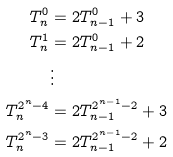Convert formula to latex. <formula><loc_0><loc_0><loc_500><loc_500>T ^ { 0 } _ { n } & = 2 T ^ { 0 } _ { n - 1 } + 3 \\ T ^ { 1 } _ { n } & = 2 T ^ { 0 } _ { n - 1 } + 2 \\ & \vdots \\ T ^ { 2 ^ { n } - 4 } _ { n } & = 2 T ^ { 2 ^ { n - 1 } - 2 } _ { n - 1 } + 3 \\ T ^ { 2 ^ { n } - 3 } _ { n } & = 2 T ^ { 2 ^ { n - 1 } - 2 } _ { n - 1 } + 2</formula> 